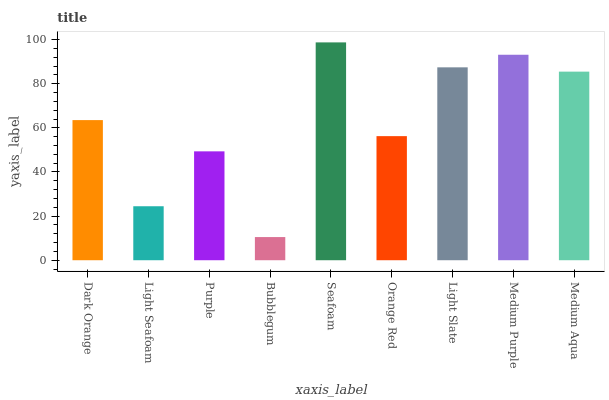Is Bubblegum the minimum?
Answer yes or no. Yes. Is Seafoam the maximum?
Answer yes or no. Yes. Is Light Seafoam the minimum?
Answer yes or no. No. Is Light Seafoam the maximum?
Answer yes or no. No. Is Dark Orange greater than Light Seafoam?
Answer yes or no. Yes. Is Light Seafoam less than Dark Orange?
Answer yes or no. Yes. Is Light Seafoam greater than Dark Orange?
Answer yes or no. No. Is Dark Orange less than Light Seafoam?
Answer yes or no. No. Is Dark Orange the high median?
Answer yes or no. Yes. Is Dark Orange the low median?
Answer yes or no. Yes. Is Light Seafoam the high median?
Answer yes or no. No. Is Medium Aqua the low median?
Answer yes or no. No. 